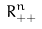<formula> <loc_0><loc_0><loc_500><loc_500>R _ { + + } ^ { n }</formula> 